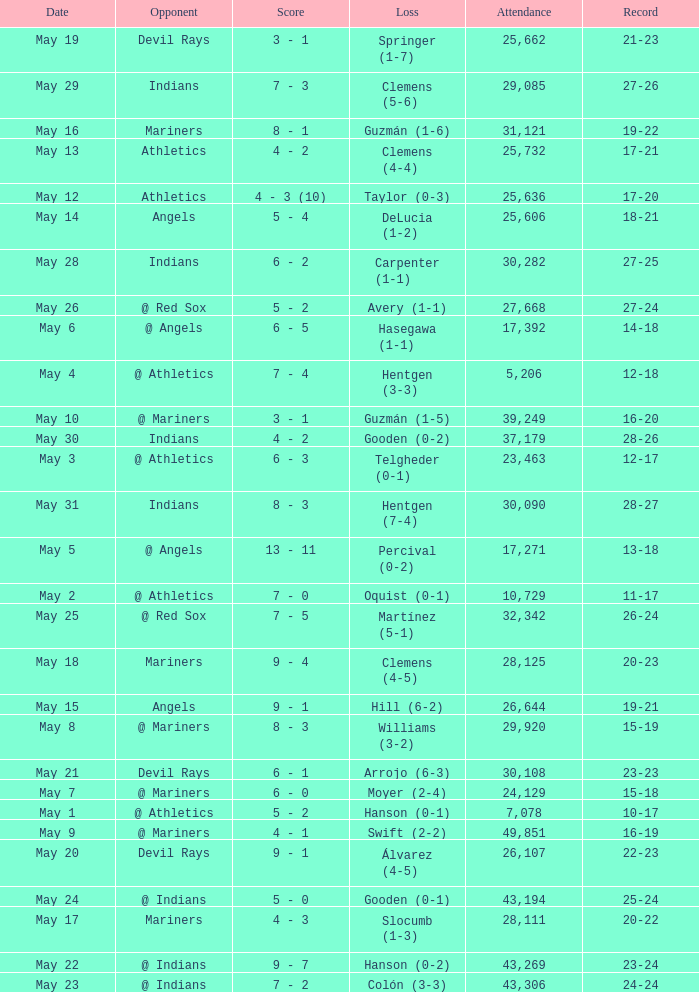What is the record for May 31? 28-27. 